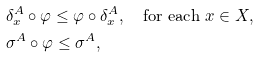Convert formula to latex. <formula><loc_0><loc_0><loc_500><loc_500>& \delta ^ { A } _ { x } \circ \varphi \leq \varphi \circ \delta ^ { A } _ { x } , \quad \text {for each} \ x \in X , \\ & \sigma ^ { A } \circ \varphi \leq \sigma ^ { A } ,</formula> 